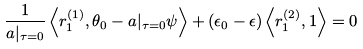<formula> <loc_0><loc_0><loc_500><loc_500>\frac { 1 } { a | _ { \tau = 0 } } \left \langle r _ { 1 } ^ { ( 1 ) } , \theta _ { 0 } - a | _ { \tau = 0 } \psi \right \rangle + ( \epsilon _ { 0 } - \epsilon ) \left \langle r _ { 1 } ^ { ( 2 ) } , 1 \right \rangle = 0</formula> 